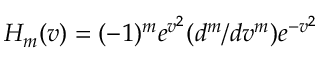Convert formula to latex. <formula><loc_0><loc_0><loc_500><loc_500>H _ { m } ( v ) = ( - 1 ) ^ { m } e ^ { v ^ { 2 } } ( d ^ { m } / d v ^ { m } ) e ^ { - v ^ { 2 } }</formula> 